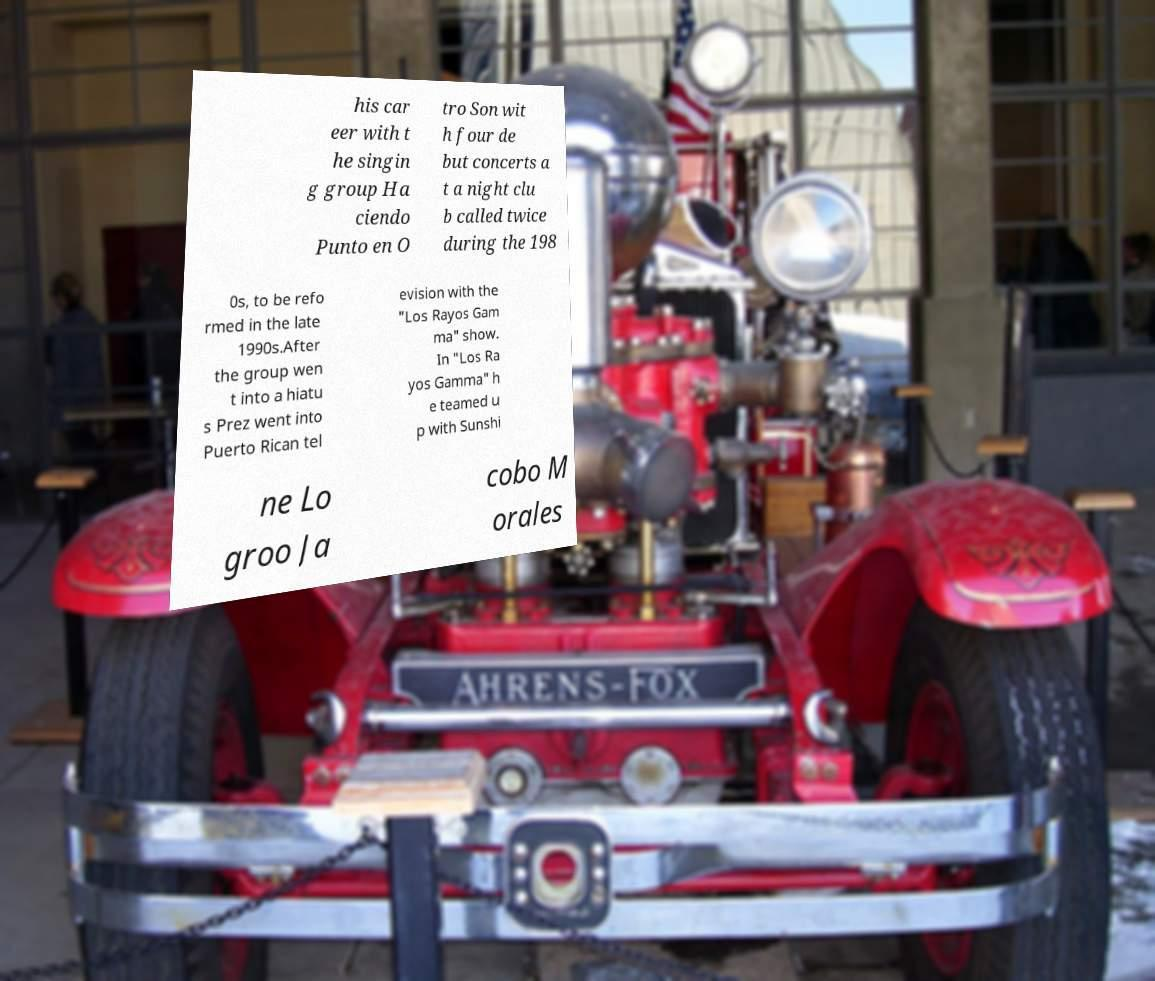Could you extract and type out the text from this image? his car eer with t he singin g group Ha ciendo Punto en O tro Son wit h four de but concerts a t a night clu b called twice during the 198 0s, to be refo rmed in the late 1990s.After the group wen t into a hiatu s Prez went into Puerto Rican tel evision with the "Los Rayos Gam ma" show. In "Los Ra yos Gamma" h e teamed u p with Sunshi ne Lo groo Ja cobo M orales 